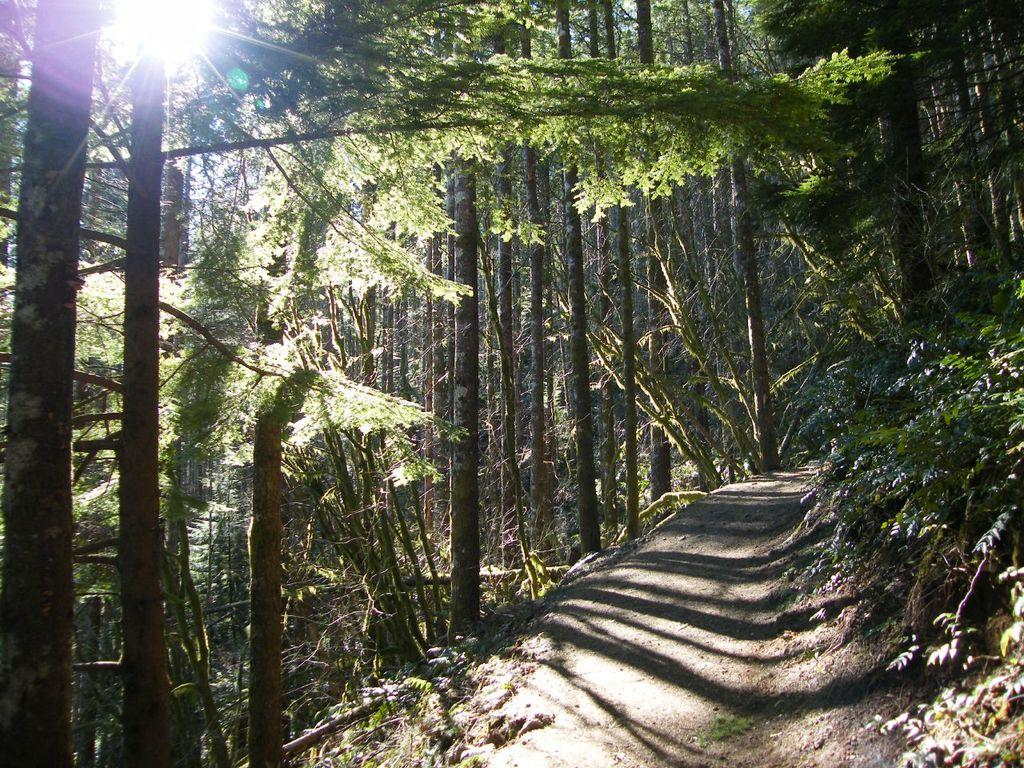What type of vegetation can be seen in the image? There are trees in the image. What natural phenomenon is visible at the top of the image? The sunrise is visible at the top of the image. What type of approval is required for the hen to cross the road in the image? There is no hen or road present in the image, so the question of approval is not applicable. 